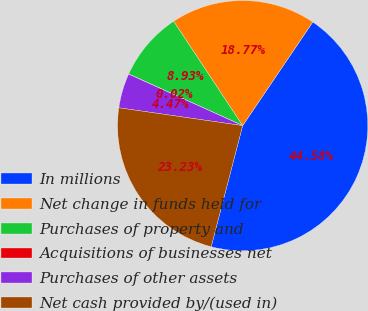Convert chart. <chart><loc_0><loc_0><loc_500><loc_500><pie_chart><fcel>In millions<fcel>Net change in funds held for<fcel>Purchases of property and<fcel>Acquisitions of businesses net<fcel>Purchases of other assets<fcel>Net cash provided by/(used in)<nl><fcel>44.58%<fcel>18.77%<fcel>8.93%<fcel>0.02%<fcel>4.47%<fcel>23.23%<nl></chart> 